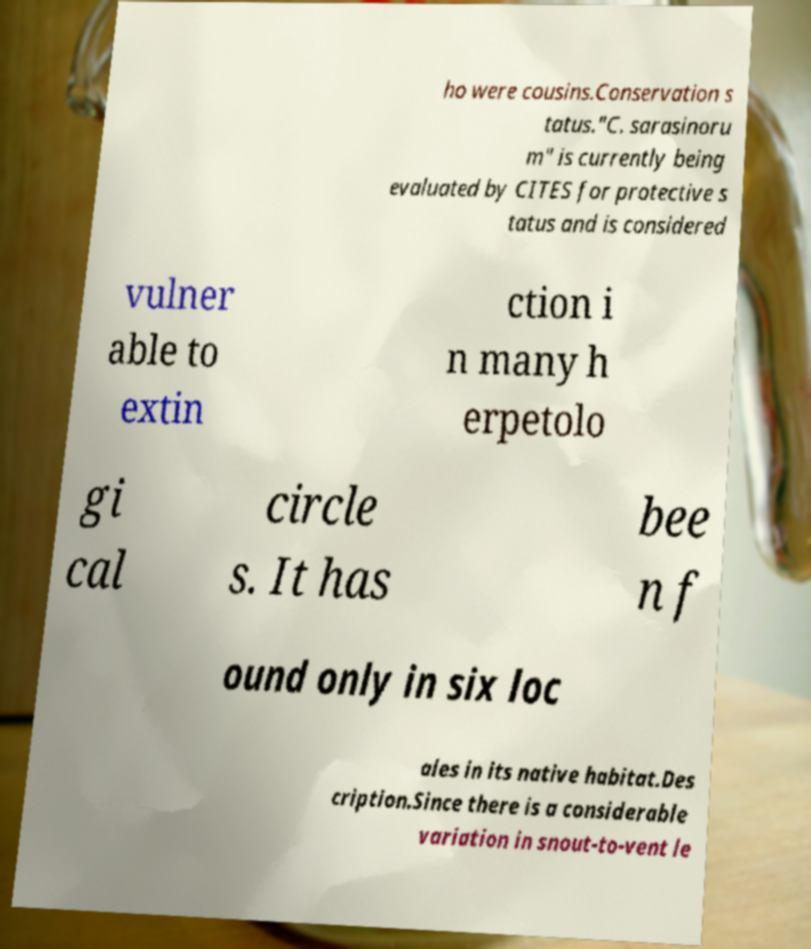Can you read and provide the text displayed in the image?This photo seems to have some interesting text. Can you extract and type it out for me? ho were cousins.Conservation s tatus."C. sarasinoru m" is currently being evaluated by CITES for protective s tatus and is considered vulner able to extin ction i n many h erpetolo gi cal circle s. It has bee n f ound only in six loc ales in its native habitat.Des cription.Since there is a considerable variation in snout-to-vent le 